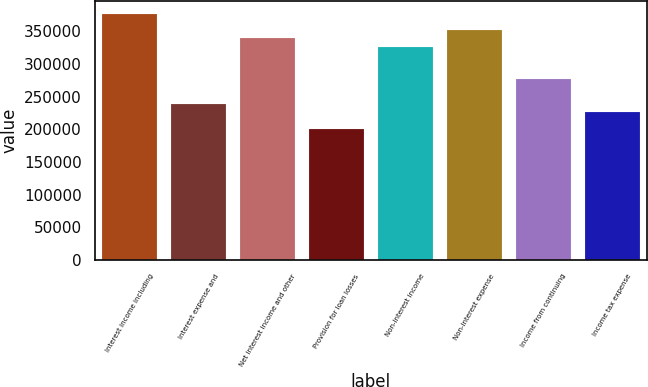Convert chart. <chart><loc_0><loc_0><loc_500><loc_500><bar_chart><fcel>Interest income including<fcel>Interest expense and<fcel>Net interest income and other<fcel>Provision for loan losses<fcel>Non-interest income<fcel>Non-interest expense<fcel>Income from continuing<fcel>Income tax expense<nl><fcel>377061<fcel>238806<fcel>339355<fcel>201100<fcel>326787<fcel>351924<fcel>276512<fcel>226237<nl></chart> 